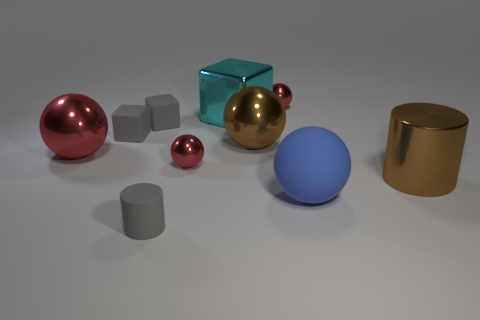Is there a red object of the same size as the blue matte thing? Yes, there is a red spherical object that appears to be of a similar size to the blue matte sphere. 